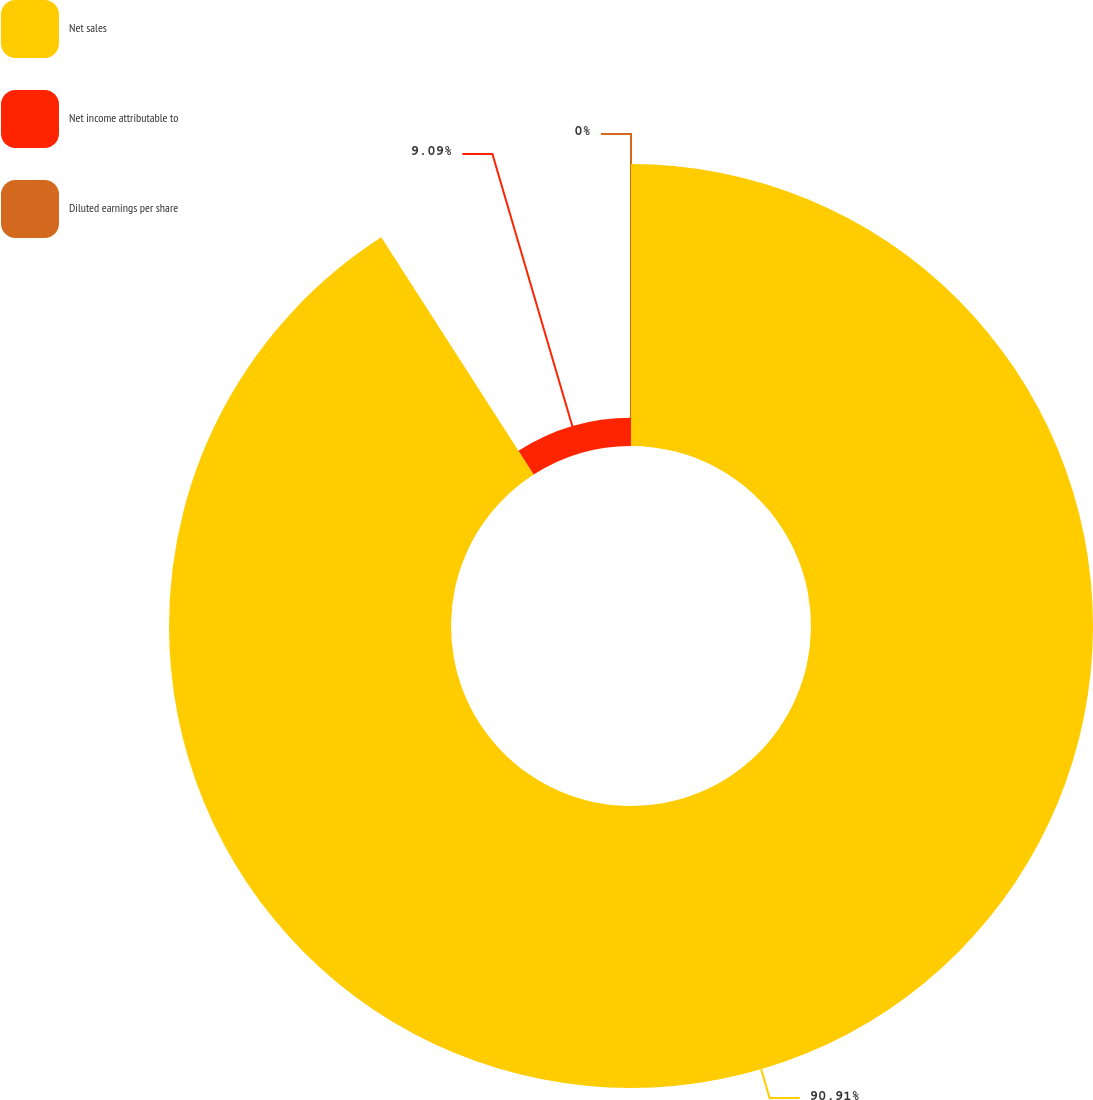<chart> <loc_0><loc_0><loc_500><loc_500><pie_chart><fcel>Net sales<fcel>Net income attributable to<fcel>Diluted earnings per share<nl><fcel>90.91%<fcel>9.09%<fcel>0.0%<nl></chart> 